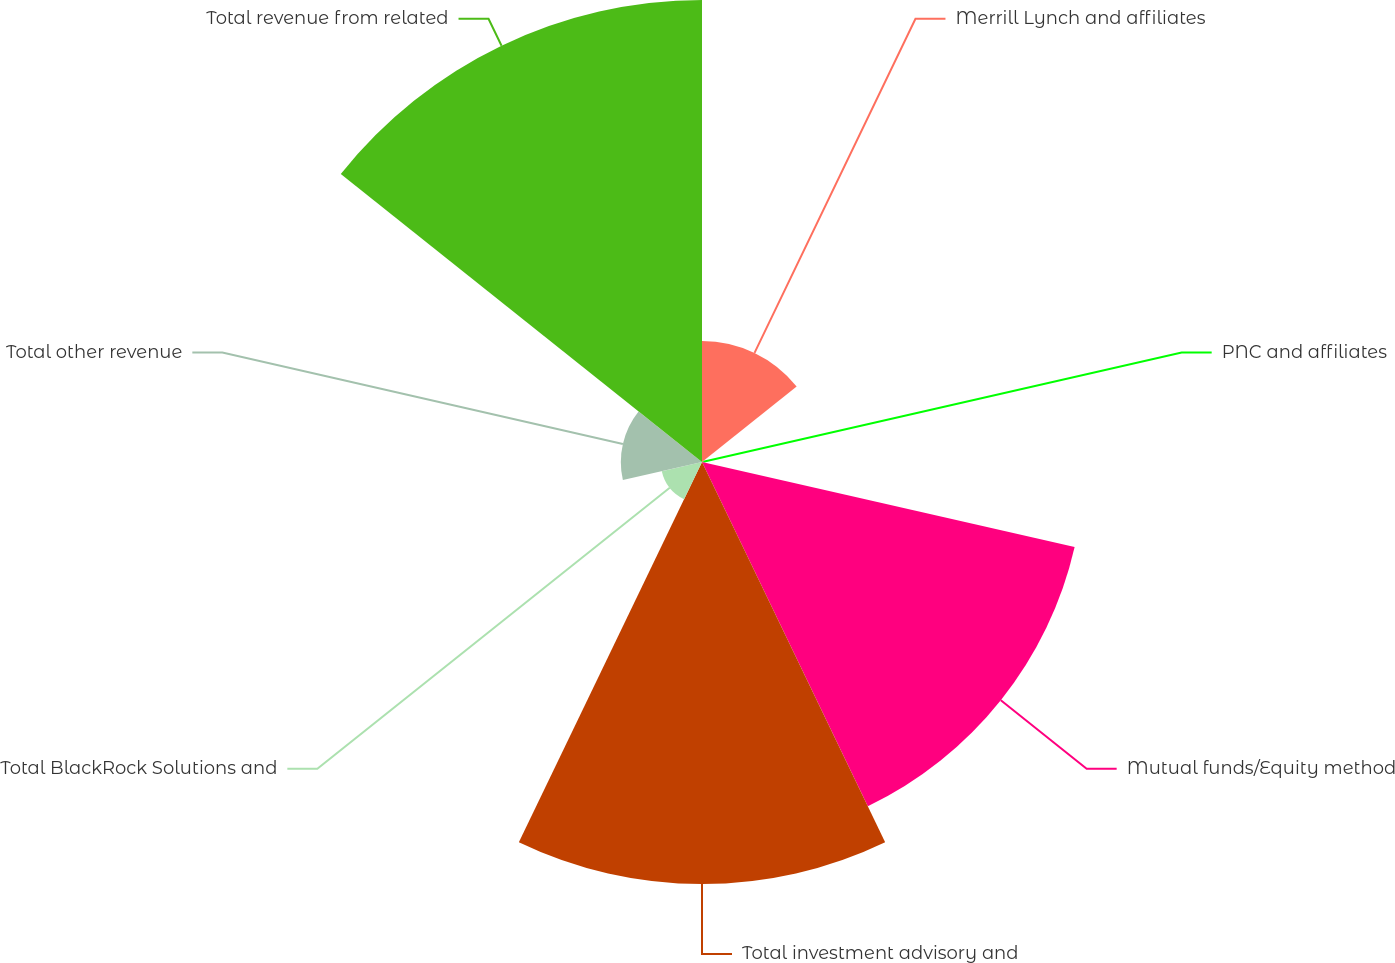<chart> <loc_0><loc_0><loc_500><loc_500><pie_chart><fcel>Merrill Lynch and affiliates<fcel>PNC and affiliates<fcel>Mutual funds/Equity method<fcel>Total investment advisory and<fcel>Total BlackRock Solutions and<fcel>Total other revenue<fcel>Total revenue from related<nl><fcel>8.01%<fcel>0.09%<fcel>25.29%<fcel>27.93%<fcel>2.73%<fcel>5.37%<fcel>30.57%<nl></chart> 